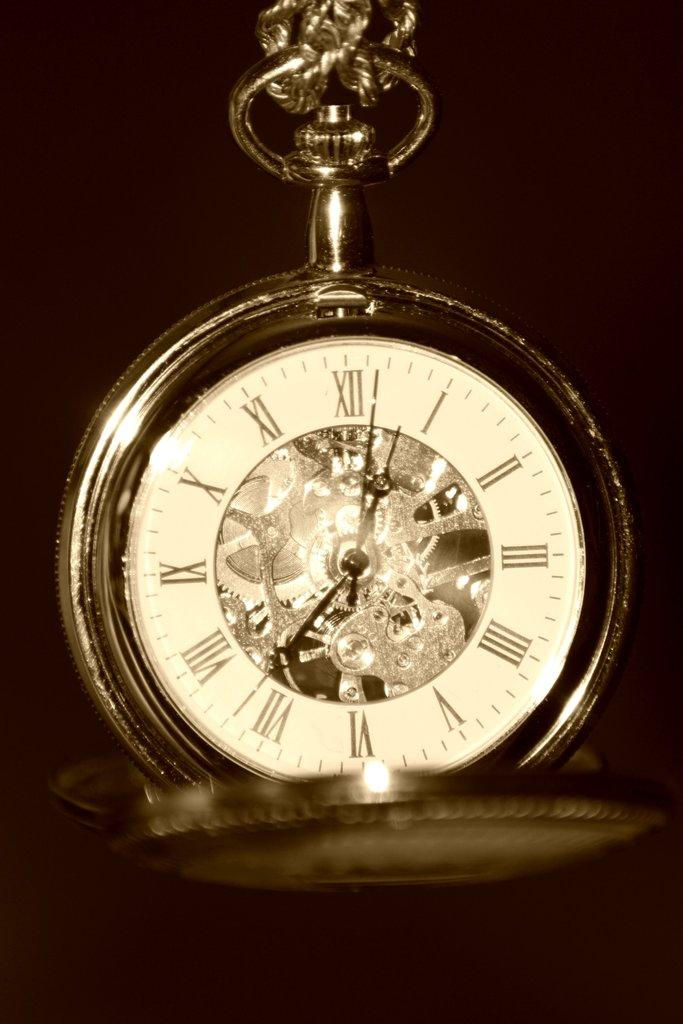<image>
Describe the image concisely. A pocket watch has a roman numeral XII at the top of the face and VI at the bottom. 